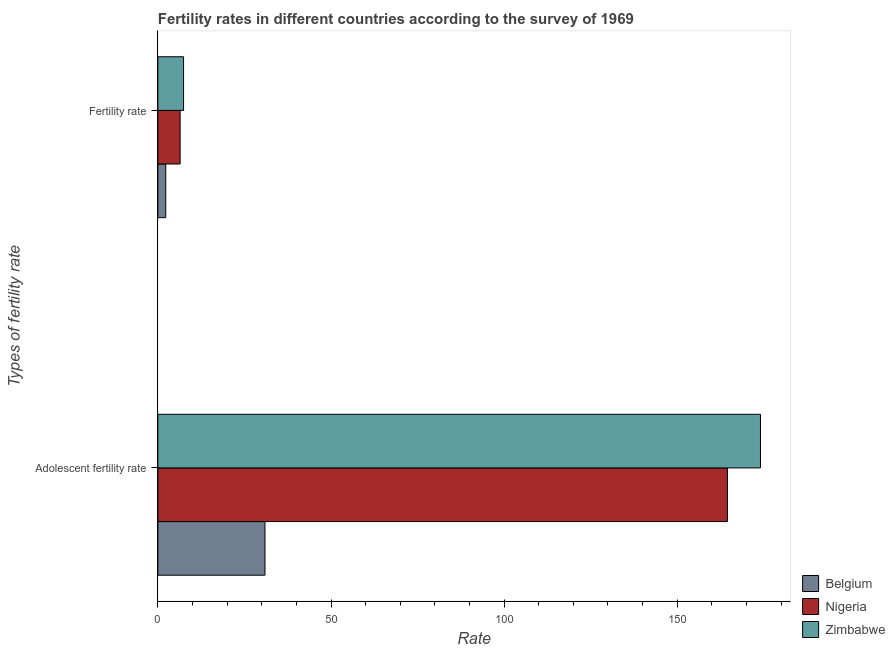How many different coloured bars are there?
Give a very brief answer. 3. Are the number of bars per tick equal to the number of legend labels?
Give a very brief answer. Yes. How many bars are there on the 1st tick from the top?
Your answer should be very brief. 3. What is the label of the 2nd group of bars from the top?
Provide a short and direct response. Adolescent fertility rate. What is the fertility rate in Belgium?
Ensure brevity in your answer.  2.27. Across all countries, what is the maximum fertility rate?
Provide a succinct answer. 7.42. Across all countries, what is the minimum fertility rate?
Your response must be concise. 2.27. In which country was the fertility rate maximum?
Make the answer very short. Zimbabwe. In which country was the adolescent fertility rate minimum?
Offer a very short reply. Belgium. What is the total adolescent fertility rate in the graph?
Offer a very short reply. 369.49. What is the difference between the adolescent fertility rate in Belgium and that in Nigeria?
Offer a terse response. -133.57. What is the difference between the fertility rate in Belgium and the adolescent fertility rate in Nigeria?
Offer a very short reply. -162.24. What is the average fertility rate per country?
Keep it short and to the point. 5.37. What is the difference between the adolescent fertility rate and fertility rate in Nigeria?
Your answer should be very brief. 158.08. What is the ratio of the adolescent fertility rate in Zimbabwe to that in Belgium?
Ensure brevity in your answer.  5.63. What does the 2nd bar from the top in Adolescent fertility rate represents?
Your answer should be compact. Nigeria. What does the 2nd bar from the bottom in Adolescent fertility rate represents?
Offer a terse response. Nigeria. Are all the bars in the graph horizontal?
Your answer should be compact. Yes. How many countries are there in the graph?
Your answer should be very brief. 3. What is the difference between two consecutive major ticks on the X-axis?
Your answer should be compact. 50. Does the graph contain grids?
Your answer should be compact. No. What is the title of the graph?
Ensure brevity in your answer.  Fertility rates in different countries according to the survey of 1969. What is the label or title of the X-axis?
Offer a very short reply. Rate. What is the label or title of the Y-axis?
Provide a short and direct response. Types of fertility rate. What is the Rate in Belgium in Adolescent fertility rate?
Make the answer very short. 30.93. What is the Rate in Nigeria in Adolescent fertility rate?
Make the answer very short. 164.51. What is the Rate of Zimbabwe in Adolescent fertility rate?
Offer a very short reply. 174.05. What is the Rate in Belgium in Fertility rate?
Offer a terse response. 2.27. What is the Rate in Nigeria in Fertility rate?
Give a very brief answer. 6.42. What is the Rate in Zimbabwe in Fertility rate?
Your answer should be compact. 7.42. Across all Types of fertility rate, what is the maximum Rate of Belgium?
Keep it short and to the point. 30.93. Across all Types of fertility rate, what is the maximum Rate of Nigeria?
Your answer should be very brief. 164.51. Across all Types of fertility rate, what is the maximum Rate of Zimbabwe?
Give a very brief answer. 174.05. Across all Types of fertility rate, what is the minimum Rate of Belgium?
Your response must be concise. 2.27. Across all Types of fertility rate, what is the minimum Rate in Nigeria?
Provide a short and direct response. 6.42. Across all Types of fertility rate, what is the minimum Rate of Zimbabwe?
Provide a short and direct response. 7.42. What is the total Rate of Belgium in the graph?
Ensure brevity in your answer.  33.2. What is the total Rate in Nigeria in the graph?
Offer a very short reply. 170.93. What is the total Rate of Zimbabwe in the graph?
Provide a succinct answer. 181.46. What is the difference between the Rate of Belgium in Adolescent fertility rate and that in Fertility rate?
Keep it short and to the point. 28.66. What is the difference between the Rate in Nigeria in Adolescent fertility rate and that in Fertility rate?
Make the answer very short. 158.08. What is the difference between the Rate in Zimbabwe in Adolescent fertility rate and that in Fertility rate?
Keep it short and to the point. 166.63. What is the difference between the Rate of Belgium in Adolescent fertility rate and the Rate of Nigeria in Fertility rate?
Give a very brief answer. 24.51. What is the difference between the Rate of Belgium in Adolescent fertility rate and the Rate of Zimbabwe in Fertility rate?
Provide a succinct answer. 23.52. What is the difference between the Rate of Nigeria in Adolescent fertility rate and the Rate of Zimbabwe in Fertility rate?
Your answer should be compact. 157.09. What is the average Rate in Belgium per Types of fertility rate?
Your answer should be very brief. 16.6. What is the average Rate in Nigeria per Types of fertility rate?
Offer a very short reply. 85.47. What is the average Rate of Zimbabwe per Types of fertility rate?
Your answer should be very brief. 90.73. What is the difference between the Rate of Belgium and Rate of Nigeria in Adolescent fertility rate?
Your response must be concise. -133.57. What is the difference between the Rate of Belgium and Rate of Zimbabwe in Adolescent fertility rate?
Your response must be concise. -143.11. What is the difference between the Rate in Nigeria and Rate in Zimbabwe in Adolescent fertility rate?
Your answer should be compact. -9.54. What is the difference between the Rate of Belgium and Rate of Nigeria in Fertility rate?
Offer a very short reply. -4.16. What is the difference between the Rate of Belgium and Rate of Zimbabwe in Fertility rate?
Your response must be concise. -5.14. What is the difference between the Rate of Nigeria and Rate of Zimbabwe in Fertility rate?
Your response must be concise. -0.99. What is the ratio of the Rate in Belgium in Adolescent fertility rate to that in Fertility rate?
Offer a very short reply. 13.63. What is the ratio of the Rate in Nigeria in Adolescent fertility rate to that in Fertility rate?
Ensure brevity in your answer.  25.6. What is the ratio of the Rate in Zimbabwe in Adolescent fertility rate to that in Fertility rate?
Ensure brevity in your answer.  23.47. What is the difference between the highest and the second highest Rate in Belgium?
Your response must be concise. 28.66. What is the difference between the highest and the second highest Rate of Nigeria?
Your response must be concise. 158.08. What is the difference between the highest and the second highest Rate of Zimbabwe?
Give a very brief answer. 166.63. What is the difference between the highest and the lowest Rate in Belgium?
Your response must be concise. 28.66. What is the difference between the highest and the lowest Rate in Nigeria?
Keep it short and to the point. 158.08. What is the difference between the highest and the lowest Rate of Zimbabwe?
Keep it short and to the point. 166.63. 